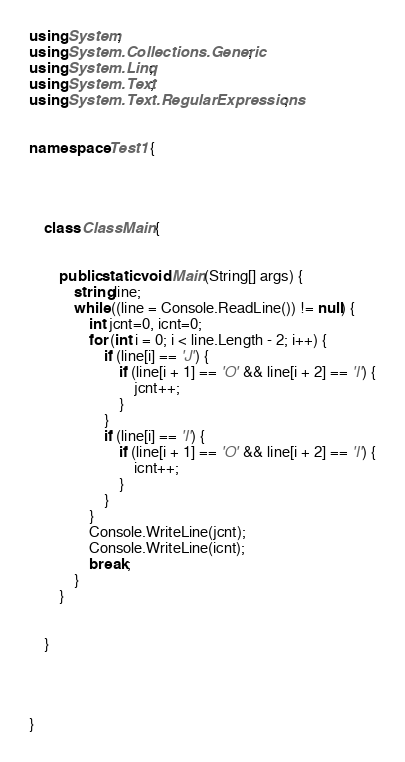Convert code to text. <code><loc_0><loc_0><loc_500><loc_500><_C#_>using System;
using System.Collections.Generic;
using System.Linq;
using System.Text;
using System.Text.RegularExpressions;


namespace Test1 {

    


    class ClassMain {

       
        public static void Main(String[] args) {
            string line;
            while ((line = Console.ReadLine()) != null) {
                int jcnt=0, icnt=0;
                for (int i = 0; i < line.Length - 2; i++) {
                    if (line[i] == 'J') {
                        if (line[i + 1] == 'O' && line[i + 2] == 'I') {
                            jcnt++;
                        }
                    }
                    if (line[i] == 'I') {
                        if (line[i + 1] == 'O' && line[i + 2] == 'I') {
                            icnt++;
                        }
                    }
                }
                Console.WriteLine(jcnt);
                Console.WriteLine(icnt);
                break;
            }
        }

        
    }



    
}</code> 